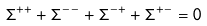<formula> <loc_0><loc_0><loc_500><loc_500>\Sigma ^ { + + } + \Sigma ^ { - - } + \Sigma ^ { - + } + \Sigma ^ { + - } = 0</formula> 